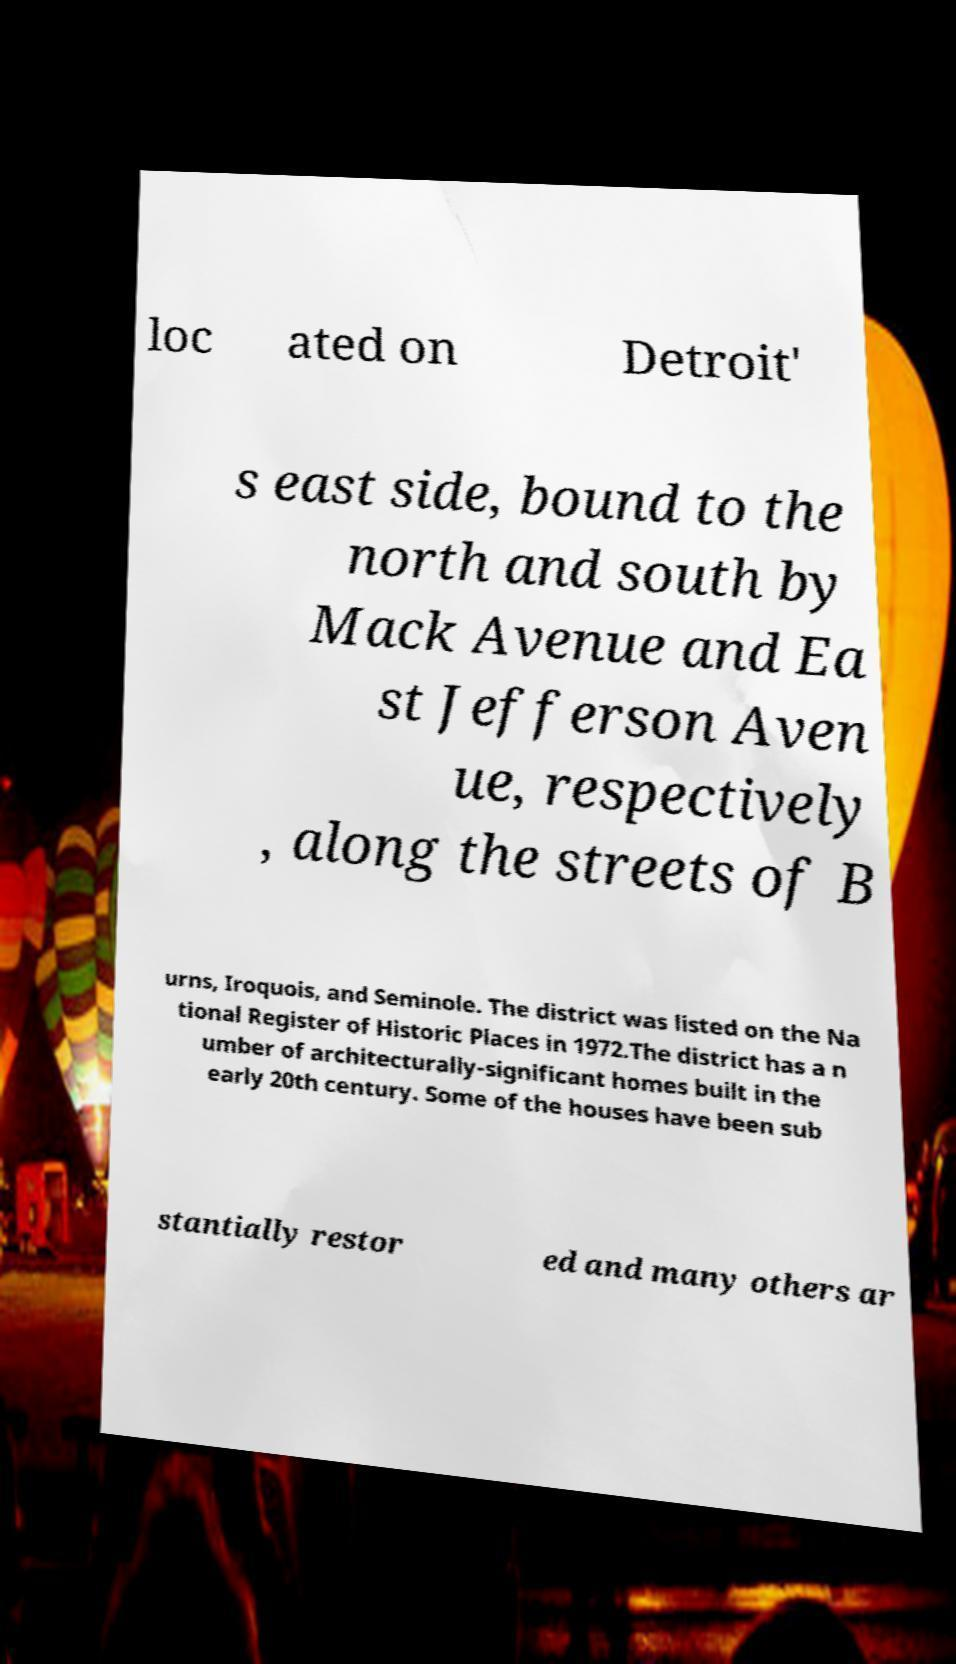Please read and relay the text visible in this image. What does it say? loc ated on Detroit' s east side, bound to the north and south by Mack Avenue and Ea st Jefferson Aven ue, respectively , along the streets of B urns, Iroquois, and Seminole. The district was listed on the Na tional Register of Historic Places in 1972.The district has a n umber of architecturally-significant homes built in the early 20th century. Some of the houses have been sub stantially restor ed and many others ar 